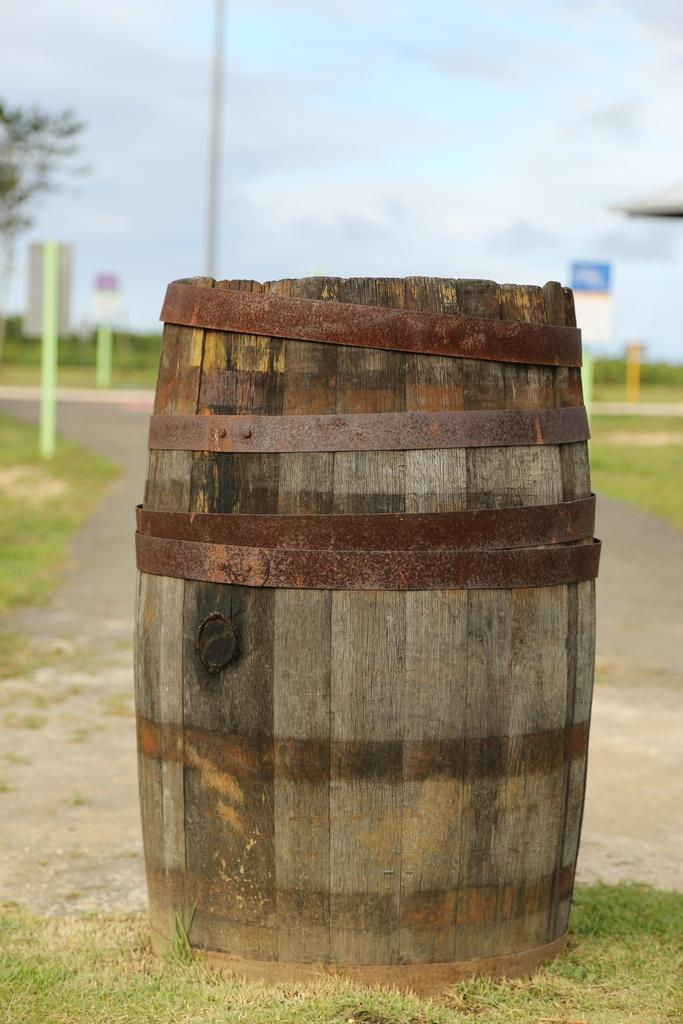What object is placed on the ground in the image? There is a barrel placed on the ground. What can be seen in the background of the image? There is a group of poles, a tree, and the sky visible in the background. What type of music can be heard coming from the car in the image? There is no car present in the image, so it's not possible to determine what, if any, music might be heard. 